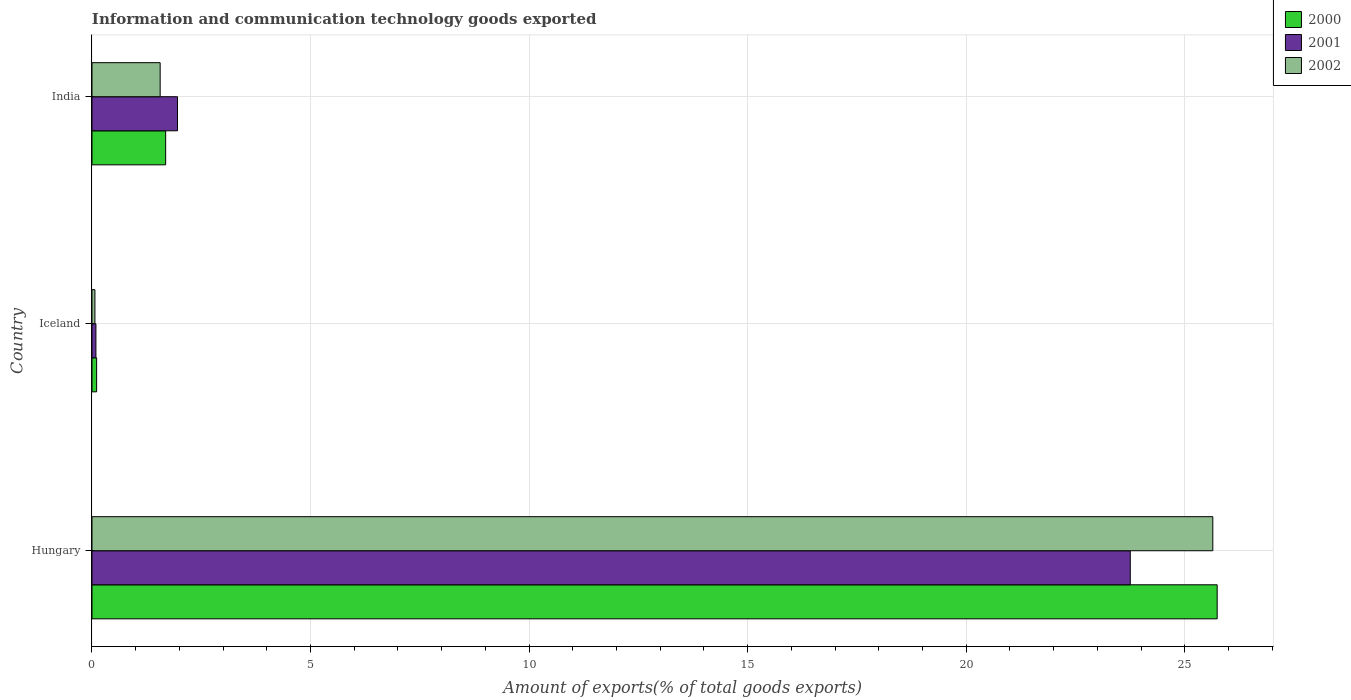How many different coloured bars are there?
Offer a terse response. 3. Are the number of bars per tick equal to the number of legend labels?
Offer a very short reply. Yes. Are the number of bars on each tick of the Y-axis equal?
Provide a succinct answer. Yes. What is the label of the 2nd group of bars from the top?
Your answer should be very brief. Iceland. What is the amount of goods exported in 2002 in Hungary?
Offer a terse response. 25.64. Across all countries, what is the maximum amount of goods exported in 2002?
Your response must be concise. 25.64. Across all countries, what is the minimum amount of goods exported in 2001?
Keep it short and to the point. 0.09. In which country was the amount of goods exported in 2002 maximum?
Your answer should be very brief. Hungary. What is the total amount of goods exported in 2002 in the graph?
Keep it short and to the point. 27.27. What is the difference between the amount of goods exported in 2001 in Hungary and that in Iceland?
Provide a short and direct response. 23.66. What is the difference between the amount of goods exported in 2002 in India and the amount of goods exported in 2001 in Iceland?
Keep it short and to the point. 1.47. What is the average amount of goods exported in 2002 per country?
Provide a succinct answer. 9.09. What is the difference between the amount of goods exported in 2000 and amount of goods exported in 2002 in India?
Provide a succinct answer. 0.13. In how many countries, is the amount of goods exported in 2002 greater than 15 %?
Provide a short and direct response. 1. What is the ratio of the amount of goods exported in 2001 in Hungary to that in Iceland?
Provide a succinct answer. 263.05. Is the amount of goods exported in 2001 in Hungary less than that in Iceland?
Give a very brief answer. No. Is the difference between the amount of goods exported in 2000 in Hungary and India greater than the difference between the amount of goods exported in 2002 in Hungary and India?
Make the answer very short. No. What is the difference between the highest and the second highest amount of goods exported in 2002?
Provide a succinct answer. 24.08. What is the difference between the highest and the lowest amount of goods exported in 2000?
Give a very brief answer. 25.64. Is the sum of the amount of goods exported in 2000 in Iceland and India greater than the maximum amount of goods exported in 2001 across all countries?
Provide a succinct answer. No. What does the 1st bar from the top in India represents?
Keep it short and to the point. 2002. How many bars are there?
Your answer should be compact. 9. Does the graph contain any zero values?
Offer a terse response. No. Where does the legend appear in the graph?
Keep it short and to the point. Top right. What is the title of the graph?
Provide a short and direct response. Information and communication technology goods exported. What is the label or title of the X-axis?
Offer a very short reply. Amount of exports(% of total goods exports). What is the label or title of the Y-axis?
Keep it short and to the point. Country. What is the Amount of exports(% of total goods exports) in 2000 in Hungary?
Make the answer very short. 25.74. What is the Amount of exports(% of total goods exports) of 2001 in Hungary?
Your response must be concise. 23.75. What is the Amount of exports(% of total goods exports) of 2002 in Hungary?
Your response must be concise. 25.64. What is the Amount of exports(% of total goods exports) of 2000 in Iceland?
Your answer should be compact. 0.11. What is the Amount of exports(% of total goods exports) in 2001 in Iceland?
Ensure brevity in your answer.  0.09. What is the Amount of exports(% of total goods exports) of 2002 in Iceland?
Keep it short and to the point. 0.07. What is the Amount of exports(% of total goods exports) in 2000 in India?
Offer a terse response. 1.69. What is the Amount of exports(% of total goods exports) of 2001 in India?
Ensure brevity in your answer.  1.96. What is the Amount of exports(% of total goods exports) of 2002 in India?
Offer a very short reply. 1.56. Across all countries, what is the maximum Amount of exports(% of total goods exports) of 2000?
Keep it short and to the point. 25.74. Across all countries, what is the maximum Amount of exports(% of total goods exports) of 2001?
Offer a terse response. 23.75. Across all countries, what is the maximum Amount of exports(% of total goods exports) in 2002?
Your response must be concise. 25.64. Across all countries, what is the minimum Amount of exports(% of total goods exports) in 2000?
Offer a terse response. 0.11. Across all countries, what is the minimum Amount of exports(% of total goods exports) in 2001?
Offer a very short reply. 0.09. Across all countries, what is the minimum Amount of exports(% of total goods exports) of 2002?
Your answer should be very brief. 0.07. What is the total Amount of exports(% of total goods exports) of 2000 in the graph?
Keep it short and to the point. 27.53. What is the total Amount of exports(% of total goods exports) in 2001 in the graph?
Offer a very short reply. 25.8. What is the total Amount of exports(% of total goods exports) of 2002 in the graph?
Keep it short and to the point. 27.27. What is the difference between the Amount of exports(% of total goods exports) of 2000 in Hungary and that in Iceland?
Your response must be concise. 25.64. What is the difference between the Amount of exports(% of total goods exports) in 2001 in Hungary and that in Iceland?
Make the answer very short. 23.66. What is the difference between the Amount of exports(% of total goods exports) of 2002 in Hungary and that in Iceland?
Ensure brevity in your answer.  25.57. What is the difference between the Amount of exports(% of total goods exports) in 2000 in Hungary and that in India?
Give a very brief answer. 24.06. What is the difference between the Amount of exports(% of total goods exports) in 2001 in Hungary and that in India?
Offer a terse response. 21.8. What is the difference between the Amount of exports(% of total goods exports) in 2002 in Hungary and that in India?
Your answer should be very brief. 24.08. What is the difference between the Amount of exports(% of total goods exports) of 2000 in Iceland and that in India?
Offer a terse response. -1.58. What is the difference between the Amount of exports(% of total goods exports) in 2001 in Iceland and that in India?
Offer a very short reply. -1.87. What is the difference between the Amount of exports(% of total goods exports) of 2002 in Iceland and that in India?
Offer a terse response. -1.49. What is the difference between the Amount of exports(% of total goods exports) in 2000 in Hungary and the Amount of exports(% of total goods exports) in 2001 in Iceland?
Make the answer very short. 25.65. What is the difference between the Amount of exports(% of total goods exports) of 2000 in Hungary and the Amount of exports(% of total goods exports) of 2002 in Iceland?
Your response must be concise. 25.67. What is the difference between the Amount of exports(% of total goods exports) of 2001 in Hungary and the Amount of exports(% of total goods exports) of 2002 in Iceland?
Keep it short and to the point. 23.69. What is the difference between the Amount of exports(% of total goods exports) of 2000 in Hungary and the Amount of exports(% of total goods exports) of 2001 in India?
Offer a very short reply. 23.79. What is the difference between the Amount of exports(% of total goods exports) in 2000 in Hungary and the Amount of exports(% of total goods exports) in 2002 in India?
Your answer should be compact. 24.18. What is the difference between the Amount of exports(% of total goods exports) of 2001 in Hungary and the Amount of exports(% of total goods exports) of 2002 in India?
Provide a short and direct response. 22.19. What is the difference between the Amount of exports(% of total goods exports) of 2000 in Iceland and the Amount of exports(% of total goods exports) of 2001 in India?
Your answer should be compact. -1.85. What is the difference between the Amount of exports(% of total goods exports) of 2000 in Iceland and the Amount of exports(% of total goods exports) of 2002 in India?
Make the answer very short. -1.45. What is the difference between the Amount of exports(% of total goods exports) of 2001 in Iceland and the Amount of exports(% of total goods exports) of 2002 in India?
Keep it short and to the point. -1.47. What is the average Amount of exports(% of total goods exports) in 2000 per country?
Provide a short and direct response. 9.18. What is the average Amount of exports(% of total goods exports) in 2001 per country?
Ensure brevity in your answer.  8.6. What is the average Amount of exports(% of total goods exports) of 2002 per country?
Your answer should be very brief. 9.09. What is the difference between the Amount of exports(% of total goods exports) of 2000 and Amount of exports(% of total goods exports) of 2001 in Hungary?
Provide a succinct answer. 1.99. What is the difference between the Amount of exports(% of total goods exports) in 2000 and Amount of exports(% of total goods exports) in 2002 in Hungary?
Give a very brief answer. 0.1. What is the difference between the Amount of exports(% of total goods exports) of 2001 and Amount of exports(% of total goods exports) of 2002 in Hungary?
Keep it short and to the point. -1.89. What is the difference between the Amount of exports(% of total goods exports) of 2000 and Amount of exports(% of total goods exports) of 2001 in Iceland?
Give a very brief answer. 0.02. What is the difference between the Amount of exports(% of total goods exports) of 2000 and Amount of exports(% of total goods exports) of 2002 in Iceland?
Provide a short and direct response. 0.04. What is the difference between the Amount of exports(% of total goods exports) in 2001 and Amount of exports(% of total goods exports) in 2002 in Iceland?
Give a very brief answer. 0.02. What is the difference between the Amount of exports(% of total goods exports) of 2000 and Amount of exports(% of total goods exports) of 2001 in India?
Provide a succinct answer. -0.27. What is the difference between the Amount of exports(% of total goods exports) in 2000 and Amount of exports(% of total goods exports) in 2002 in India?
Make the answer very short. 0.13. What is the difference between the Amount of exports(% of total goods exports) of 2001 and Amount of exports(% of total goods exports) of 2002 in India?
Make the answer very short. 0.4. What is the ratio of the Amount of exports(% of total goods exports) in 2000 in Hungary to that in Iceland?
Keep it short and to the point. 242.46. What is the ratio of the Amount of exports(% of total goods exports) in 2001 in Hungary to that in Iceland?
Your response must be concise. 263.05. What is the ratio of the Amount of exports(% of total goods exports) in 2002 in Hungary to that in Iceland?
Keep it short and to the point. 380.25. What is the ratio of the Amount of exports(% of total goods exports) of 2000 in Hungary to that in India?
Ensure brevity in your answer.  15.27. What is the ratio of the Amount of exports(% of total goods exports) of 2001 in Hungary to that in India?
Your answer should be compact. 12.14. What is the ratio of the Amount of exports(% of total goods exports) in 2002 in Hungary to that in India?
Make the answer very short. 16.44. What is the ratio of the Amount of exports(% of total goods exports) in 2000 in Iceland to that in India?
Provide a succinct answer. 0.06. What is the ratio of the Amount of exports(% of total goods exports) of 2001 in Iceland to that in India?
Ensure brevity in your answer.  0.05. What is the ratio of the Amount of exports(% of total goods exports) of 2002 in Iceland to that in India?
Ensure brevity in your answer.  0.04. What is the difference between the highest and the second highest Amount of exports(% of total goods exports) of 2000?
Make the answer very short. 24.06. What is the difference between the highest and the second highest Amount of exports(% of total goods exports) in 2001?
Your answer should be very brief. 21.8. What is the difference between the highest and the second highest Amount of exports(% of total goods exports) in 2002?
Provide a succinct answer. 24.08. What is the difference between the highest and the lowest Amount of exports(% of total goods exports) in 2000?
Provide a succinct answer. 25.64. What is the difference between the highest and the lowest Amount of exports(% of total goods exports) of 2001?
Offer a very short reply. 23.66. What is the difference between the highest and the lowest Amount of exports(% of total goods exports) of 2002?
Offer a terse response. 25.57. 